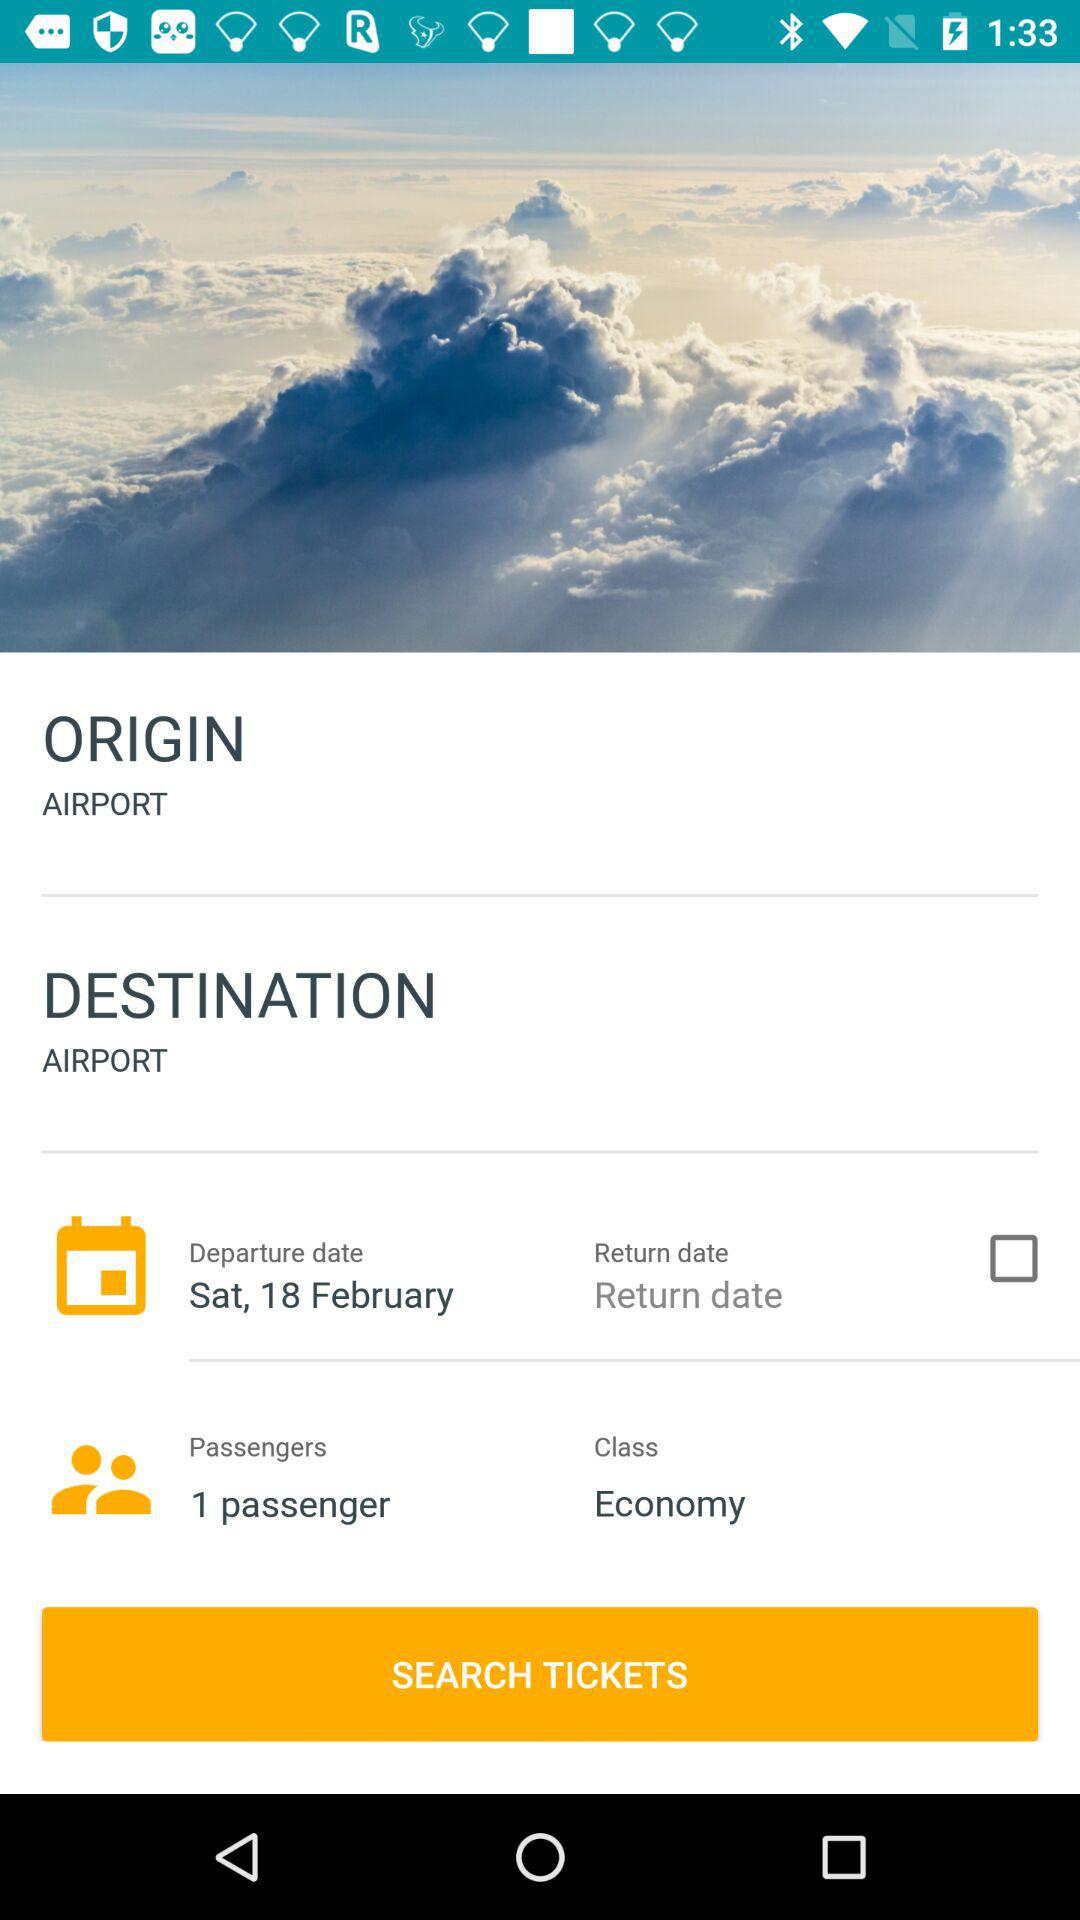What date was selected for departure? The selected date was Saturday, February 18. 